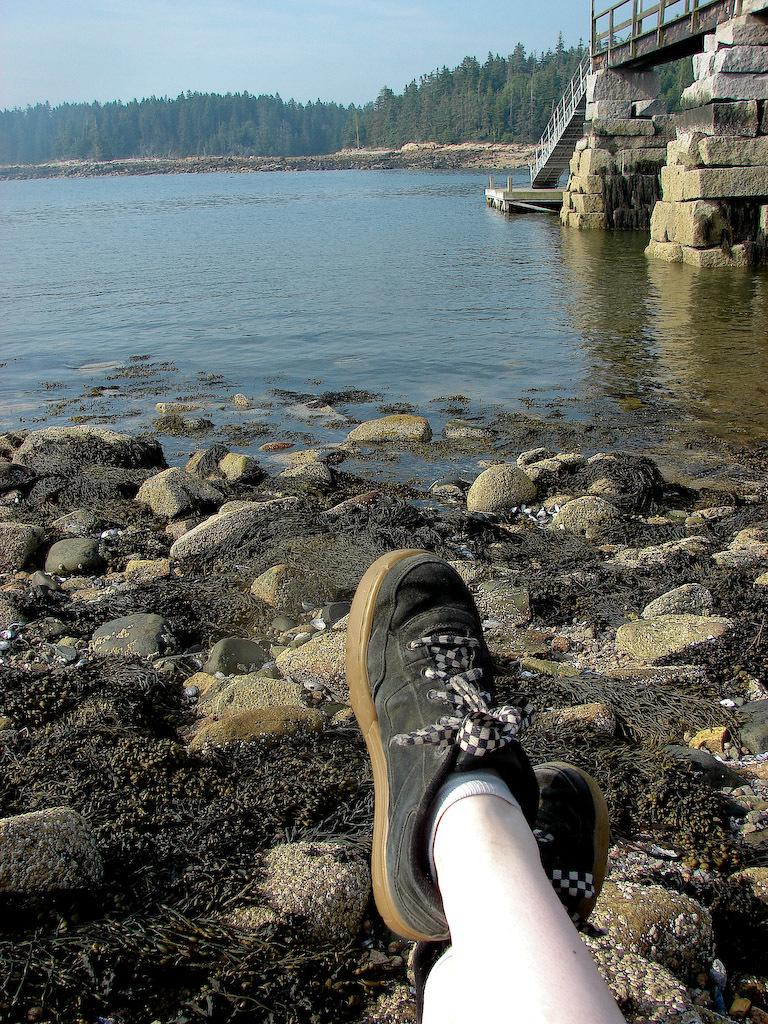What can be seen at the bottom of the image? There are a person's legs and black shoes in the image. What type of terrain is visible in the image? There are stones in the image. What architectural feature is present in the image? There are stairs in the image. What structure is visible in the image that allows people to cross over water? There is a bridge in the image. What natural element is present in the image? There is water in the image. What type of vegetation is present in the image? There are trees in the image. What is the color of the sky in the image? The sky is blue in color. What type of popcorn is being served at the event in the image? There is no event or popcorn present in the image. 